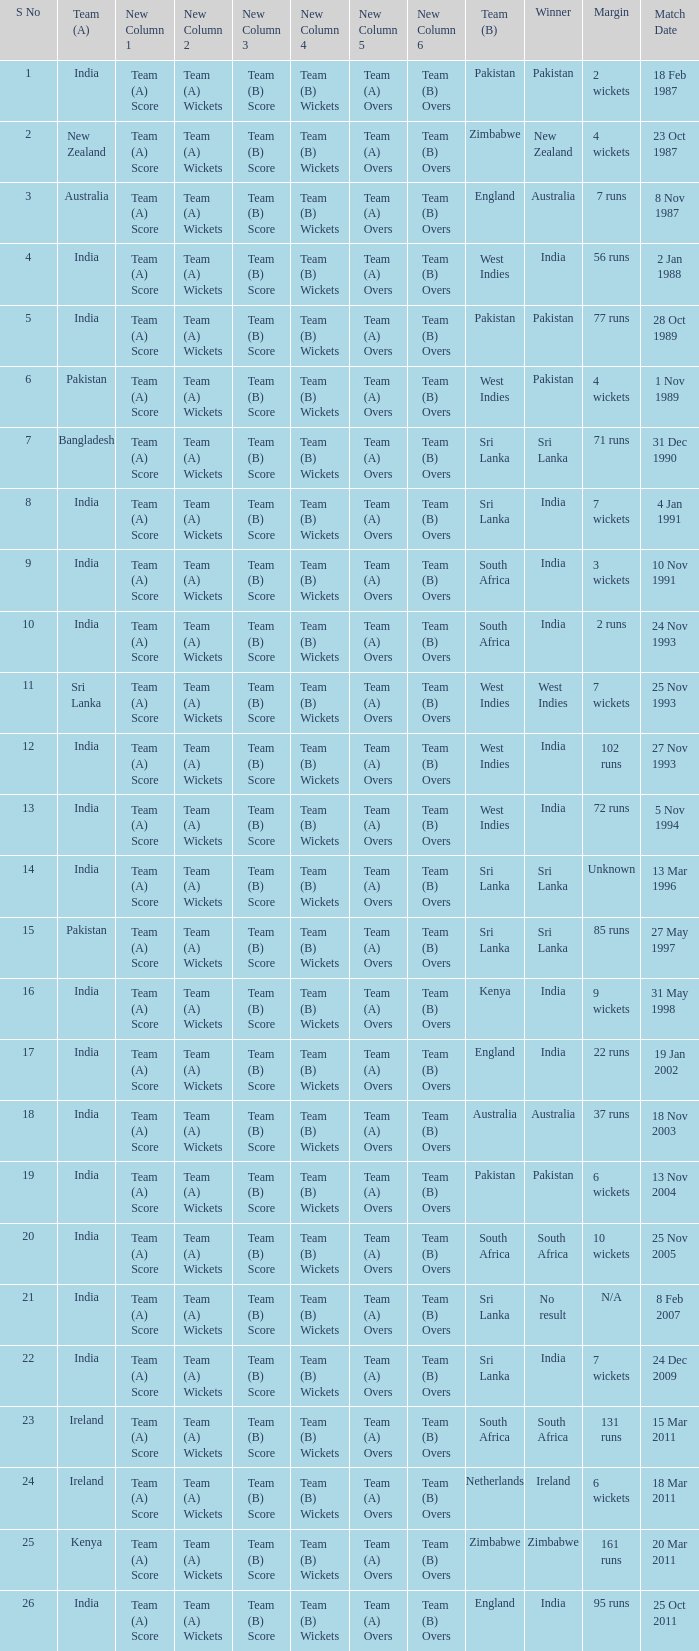What date did the West Indies win the match? 25 Nov 1993. 